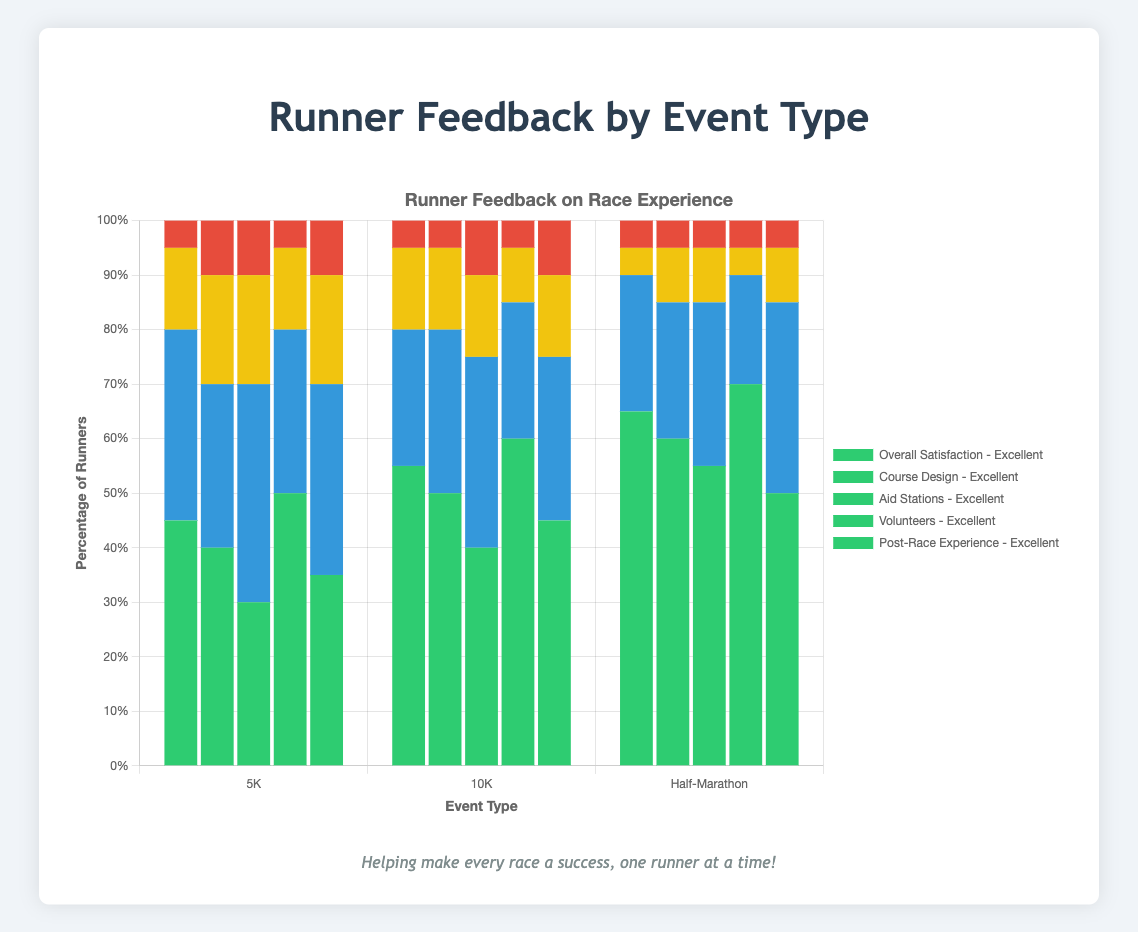What percentage of runners rated "Volunteers" as "Excellent" in the Half-Marathon? Look at the Half-Marathon section under "Volunteers" and note the height of the "Excellent" bar. It is 70% in the data.
Answer: 70% Which event type received the highest percentage of "Poor" ratings for "Aid Stations"? Compare the "Poor" ratings under "Aid Stations" for all event types. The 5K and 10K both received 10%, but the Half-Marathon received 5%.
Answer: 5K and 10K How many categories are there where the 5K event has the highest "Excellent" ratings compared to the other events? Compare the "Excellent" ratings for each category across the 5K, 10K, and Half-Marathon events and count how many times the 5K leads.
Answer: 0 In the 10K event, which category received the most "Good" ratings? Look at the "Good" ratings for all categories in the 10K event and identify the highest value. The highest "Good" rating is 35% under "Aid Stations."
Answer: Aid Stations What is the difference between the "Excellent" ratings for "Course Design" in the 10K and Half-Marathon events? Subtract the "Excellent" rating of 10K (50%) from that of Half-Marathon (60%) for "Course Design."
Answer: 10% Which feedback category has the least variance in "Excellent" ratings across all event types? Calculate the variance for "Excellent" ratings in each category across all event types. "Overall Satisfaction" with the values 45%, 55%, and 65% has the least variance.
Answer: Overall Satisfaction How does the percentage of "Average" ratings for "Post-Race Experience" in the 5K compare to the Half-Marathon? Look at the "Average" ratings for "Post-Race Experience" in the 5K (20%) and Half-Marathon (10%) and note the difference.
Answer: 10 percentage points higher What can you infer about volunteers' performance across all event types from the "Excellent" ratings? Notice that the "Excellent" ratings for volunteers are consistently high across all events: 50% for 5K, 60% for 10K, and 70% for Half-Marathon, indicating a positive perception of volunteers.
Answer: Volunteers are highly rated Which category showed the smallest overall satisfaction in the 10K event? Look at all the categories with their aggregated ratings in the 10K event and find the one with the lowest cumulative rating.
Answer: Course Design What is the average of "Good" ratings across all event types for "Course Design"? Add the "Good" ratings for "Course Design" for all event types (30% for 5K, 30% for 10K, 25% for Half-Marathon) and divide by the number of event types (3).
Answer: 28.33% 